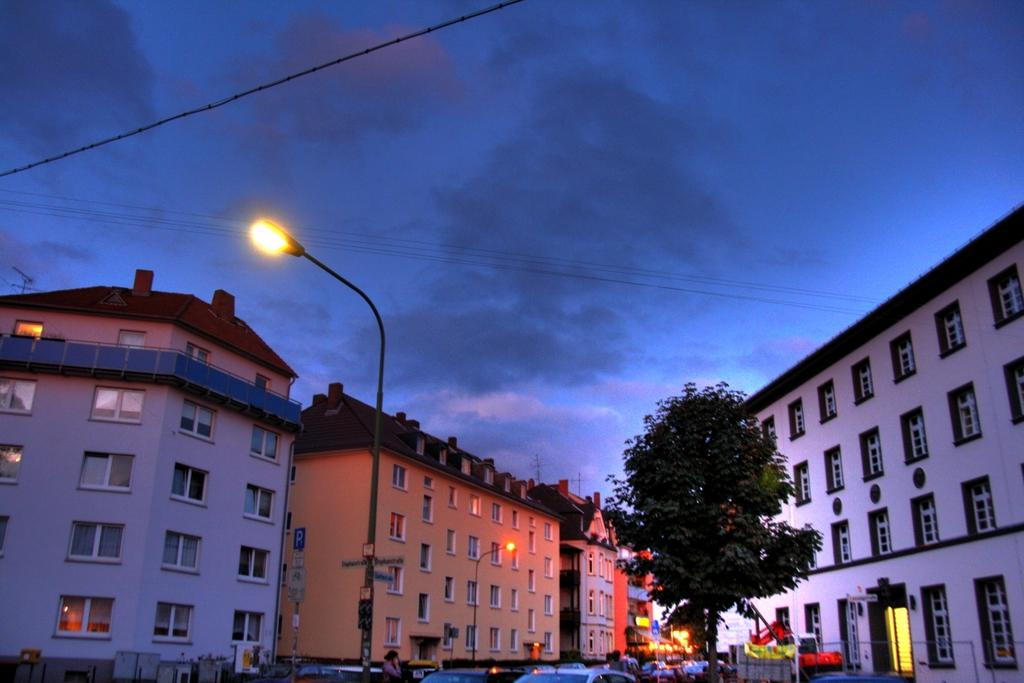What type of location is depicted in the image? The image is of a city. What can be seen moving in the image? There are vehicles in the image. What structures are present in the image? There are poles, lights, and buildings in the image. What is visible in the background of the image? The sky is visible in the background of the image. What emotion is the city expressing in the image? Cities do not express emotions; they are inanimate structures. What type of writing instrument is being used by the city in the image? There is no writing instrument present in the image, as cities do not use such tools. 